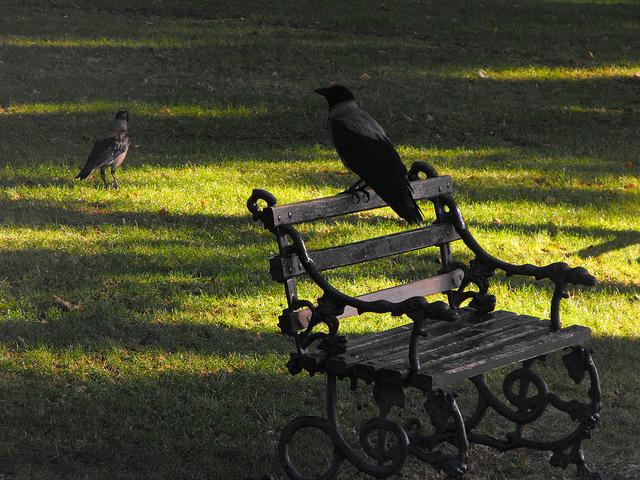How many birds are in the picture?
Answer briefly. 2. What holds the boards together?
Short answer required. Metal. How many adults would comfortably fit on this bench?
Answer briefly. 1. 